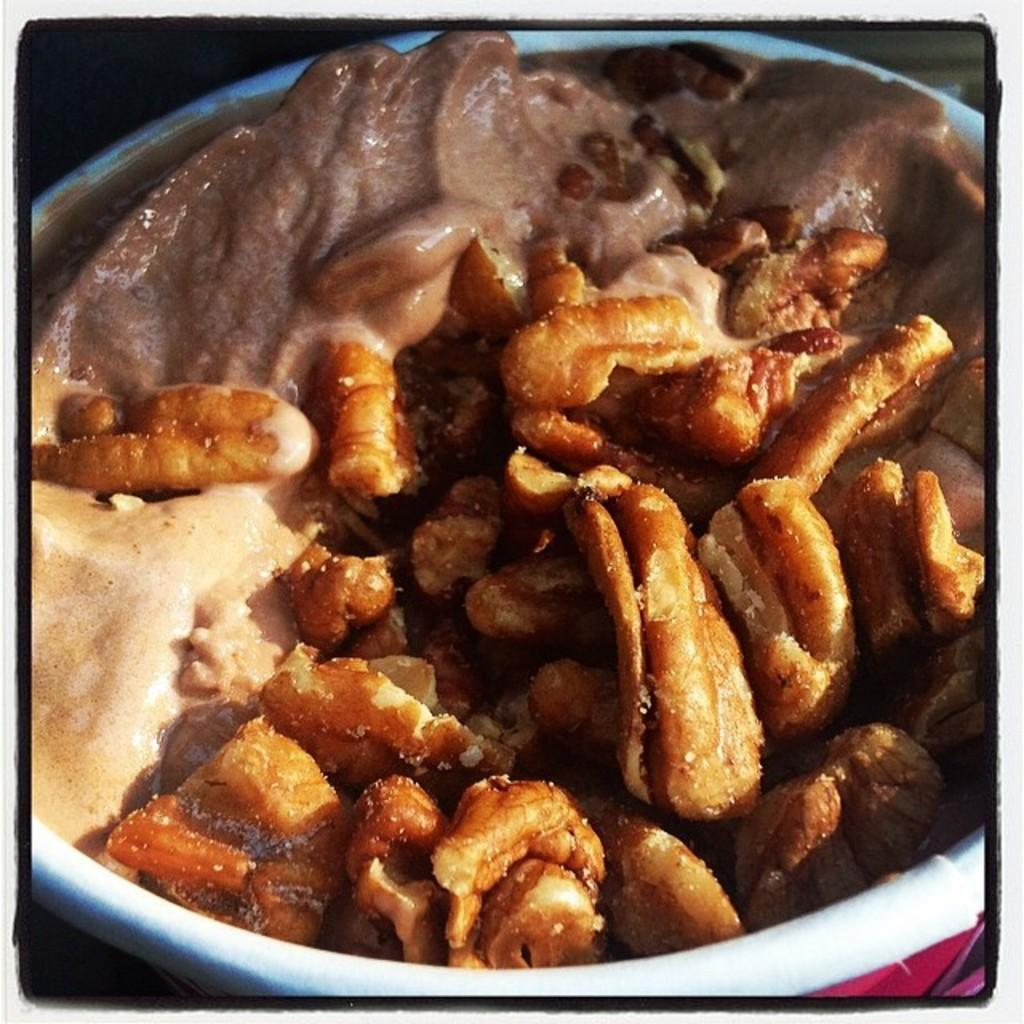What is in the bowl that is visible in the image? There is a bowl in the image, and it contains walnuts and ice cream. What type of nuts are in the bowl? The bowl contains walnuts. What is the other main ingredient in the bowl? The bowl also contains ice cream. How many beds are visible in the image? There are no beds present in the image; it only features a bowl containing walnuts and ice cream. 